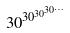Convert formula to latex. <formula><loc_0><loc_0><loc_500><loc_500>3 0 ^ { 3 0 ^ { 3 0 ^ { 3 0 ^ { \dots } } } }</formula> 